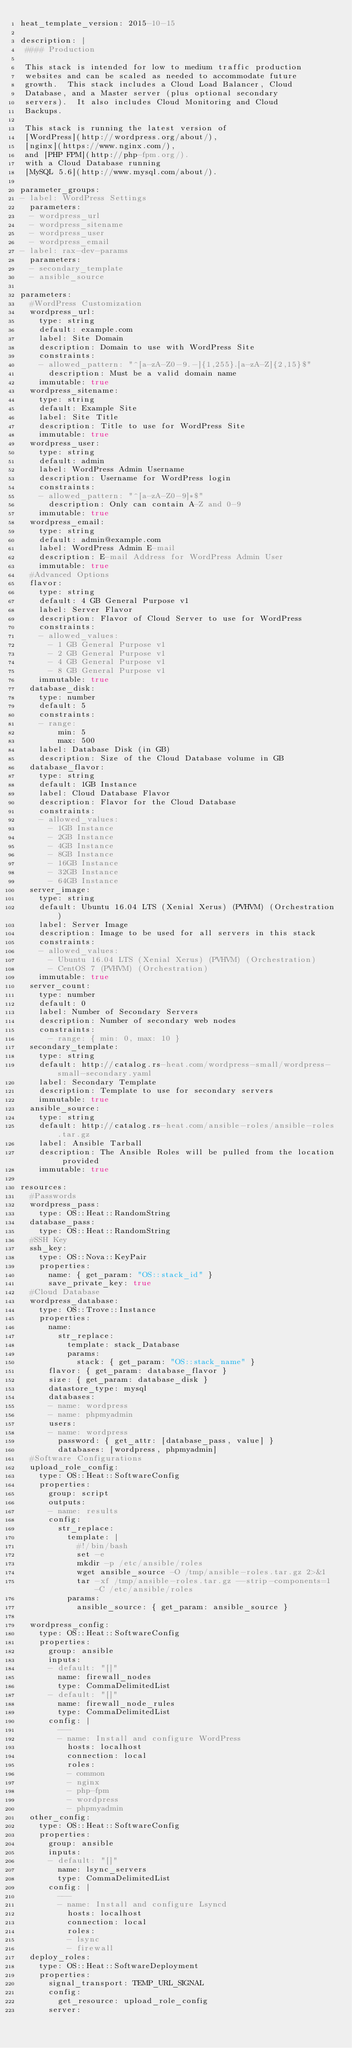<code> <loc_0><loc_0><loc_500><loc_500><_YAML_>heat_template_version: 2015-10-15

description: |
 #### Production

 This stack is intended for low to medium traffic production
 websites and can be scaled as needed to accommodate future
 growth.  This stack includes a Cloud Load Balancer, Cloud
 Database, and a Master server (plus optional secondary
 servers).  It also includes Cloud Monitoring and Cloud
 Backups.

 This stack is running the latest version of
 [WordPress](http://wordpress.org/about/),
 [nginx](https://www.nginx.com/),
 and [PHP FPM](http://php-fpm.org/).
 with a Cloud Database running
 [MySQL 5.6](http://www.mysql.com/about/).

parameter_groups:
- label: WordPress Settings
  parameters:
  - wordpress_url
  - wordpress_sitename
  - wordpress_user
  - wordpress_email
- label: rax-dev-params
  parameters:
  - secondary_template
  - ansible_source

parameters:
  #WordPress Customization
  wordpress_url:
    type: string
    default: example.com
    label: Site Domain
    description: Domain to use with WordPress Site
    constraints:
    - allowed_pattern: "^[a-zA-Z0-9.-]{1,255}.[a-zA-Z]{2,15}$"
      description: Must be a valid domain name
    immutable: true
  wordpress_sitename:
    type: string
    default: Example Site
    label: Site Title
    description: Title to use for WordPress Site
    immutable: true
  wordpress_user:
    type: string
    default: admin
    label: WordPress Admin Username
    description: Username for WordPress login
    constraints:
    - allowed_pattern: "^[a-zA-Z0-9]*$"
      description: Only can contain A-Z and 0-9
    immutable: true
  wordpress_email:
    type: string
    default: admin@example.com
    label: WordPress Admin E-mail
    description: E-mail Address for WordPress Admin User
    immutable: true
  #Advanced Options
  flavor:
    type: string
    default: 4 GB General Purpose v1
    label: Server Flavor
    description: Flavor of Cloud Server to use for WordPress
    constraints:
    - allowed_values:
      - 1 GB General Purpose v1
      - 2 GB General Purpose v1
      - 4 GB General Purpose v1
      - 8 GB General Purpose v1
    immutable: true
  database_disk:
    type: number
    default: 5
    constraints:
    - range:
        min: 5
        max: 500
    label: Database Disk (in GB)
    description: Size of the Cloud Database volume in GB
  database_flavor:
    type: string
    default: 1GB Instance
    label: Cloud Database Flavor
    description: Flavor for the Cloud Database
    constraints:
    - allowed_values:
      - 1GB Instance
      - 2GB Instance
      - 4GB Instance
      - 8GB Instance
      - 16GB Instance
      - 32GB Instance
      - 64GB Instance
  server_image:
    type: string
    default: Ubuntu 16.04 LTS (Xenial Xerus) (PVHVM) (Orchestration)
    label: Server Image
    description: Image to be used for all servers in this stack
    constraints:
    - allowed_values:
      - Ubuntu 16.04 LTS (Xenial Xerus) (PVHVM) (Orchestration)
      - CentOS 7 (PVHVM) (Orchestration)
    immutable: true
  server_count:
    type: number
    default: 0
    label: Number of Secondary Servers
    description: Number of secondary web nodes
    constraints:
      - range: { min: 0, max: 10 }
  secondary_template:
    type: string
    default: http://catalog.rs-heat.com/wordpress-small/wordpress-small-secondary.yaml
    label: Secondary Template
    description: Template to use for secondary servers
    immutable: true
  ansible_source:
    type: string
    default: http://catalog.rs-heat.com/ansible-roles/ansible-roles.tar.gz
    label: Ansible Tarball
    description: The Ansible Roles will be pulled from the location provided
    immutable: true

resources:
  #Passwords
  wordpress_pass:
    type: OS::Heat::RandomString
  database_pass:
    type: OS::Heat::RandomString
  #SSH Key
  ssh_key:
    type: OS::Nova::KeyPair
    properties:
      name: { get_param: "OS::stack_id" }
      save_private_key: true
  #Cloud Database
  wordpress_database:
    type: OS::Trove::Instance
    properties:
      name:
        str_replace:
          template: stack_Database
          params:
            stack: { get_param: "OS::stack_name" }
      flavor: { get_param: database_flavor }
      size: { get_param: database_disk }
      datastore_type: mysql
      databases:
      - name: wordpress
      - name: phpmyadmin
      users:
      - name: wordpress
        password: { get_attr: [database_pass, value] }
        databases: [wordpress, phpmyadmin]
  #Software Configurations
  upload_role_config:
    type: OS::Heat::SoftwareConfig
    properties:
      group: script
      outputs:
      - name: results
      config:
        str_replace:
          template: |
            #!/bin/bash
            set -e
            mkdir -p /etc/ansible/roles
            wget ansible_source -O /tmp/ansible-roles.tar.gz 2>&1
            tar -xf /tmp/ansible-roles.tar.gz --strip-components=1 -C /etc/ansible/roles
          params:
            ansible_source: { get_param: ansible_source }

  wordpress_config:
    type: OS::Heat::SoftwareConfig
    properties:
      group: ansible
      inputs:
      - default: "[]"
        name: firewall_nodes
        type: CommaDelimitedList
      - default: "[]"
        name: firewall_node_rules
        type: CommaDelimitedList
      config: |
        ---
        - name: Install and configure WordPress
          hosts: localhost
          connection: local
          roles:
          - common
          - nginx
          - php-fpm
          - wordpress
          - phpmyadmin
  other_config:
    type: OS::Heat::SoftwareConfig
    properties:
      group: ansible
      inputs:
      - default: "[]"
        name: lsync_servers
        type: CommaDelimitedList
      config: |
        ---
        - name: Install and configure Lsyncd
          hosts: localhost
          connection: local
          roles:
          - lsync
          - firewall
  deploy_roles:
    type: OS::Heat::SoftwareDeployment
    properties:
      signal_transport: TEMP_URL_SIGNAL
      config:
        get_resource: upload_role_config
      server:</code> 